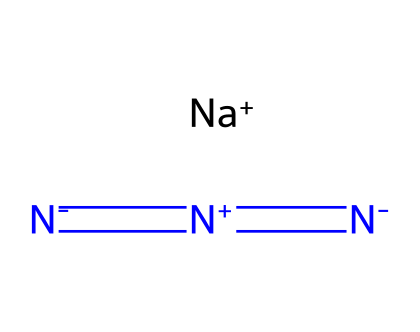What is the total number of nitrogen atoms in sodium azide? The SMILES notation indicates there are three nitrogen atoms (N) in the molecular structure, as identified by the three occurrences of "N" in the representation.
Answer: three How many sodium ions are present in sodium azide? In the provided SMILES, "[Na+]" indicates that there is one sodium ion present in the chemical structure.
Answer: one What type of bonding is observed between the nitrogen atoms? The "=" signs in the SMILES representation indicate double bonds between the nitrogen atoms, showing that they are connected through multiple bonds.
Answer: double bonds What functional group characterizes sodium azide? The presence of the azide functional group, represented by the three nitrogen atoms bonded in a sequence, is characteristic of sodium azide.
Answer: azide Why is sodium azide used in airbags? Sodium azide decomposes rapidly upon heating to produce nitrogen gas, which is essential for the rapid inflation of airbags in vehicles.
Answer: nitrogen gas How does the structure impact the stability of sodium azide? The presence of multiple nitrogen (N) atoms and the nature of azide bonding (notably the instability of the azide moiety) contribute to its overall tendency to decompose, affecting its storage and handling.
Answer: instability 